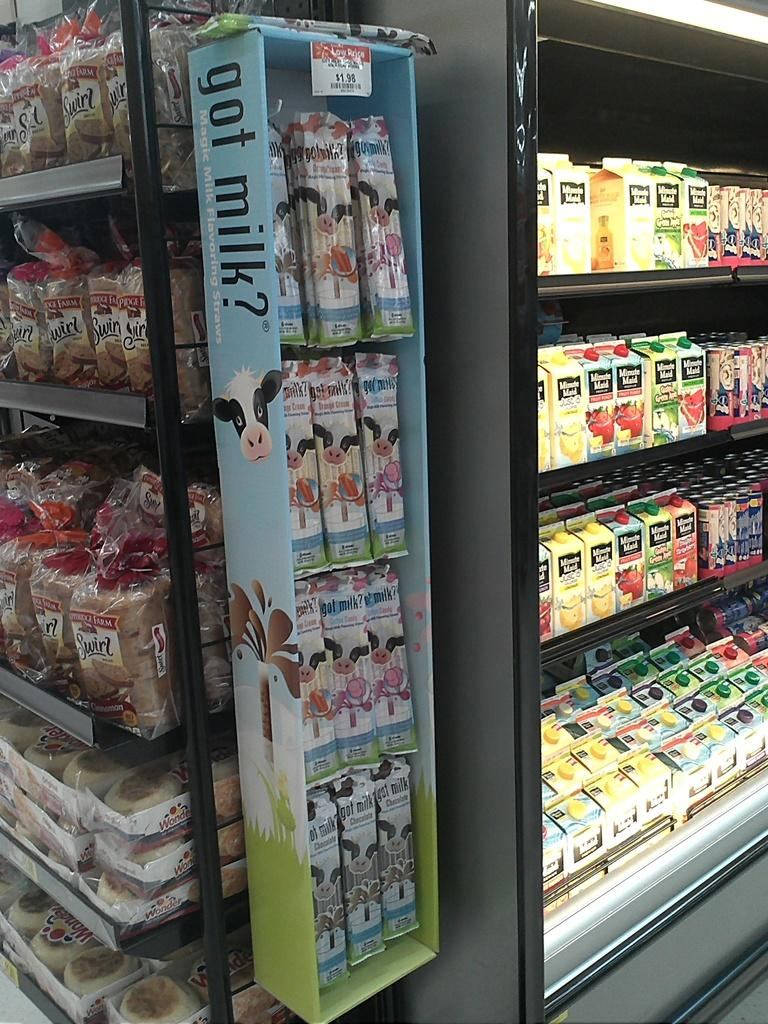<image>
Offer a succinct explanation of the picture presented. a grocery store aisle with minute maid juice, snacks with a cow on them and bread 